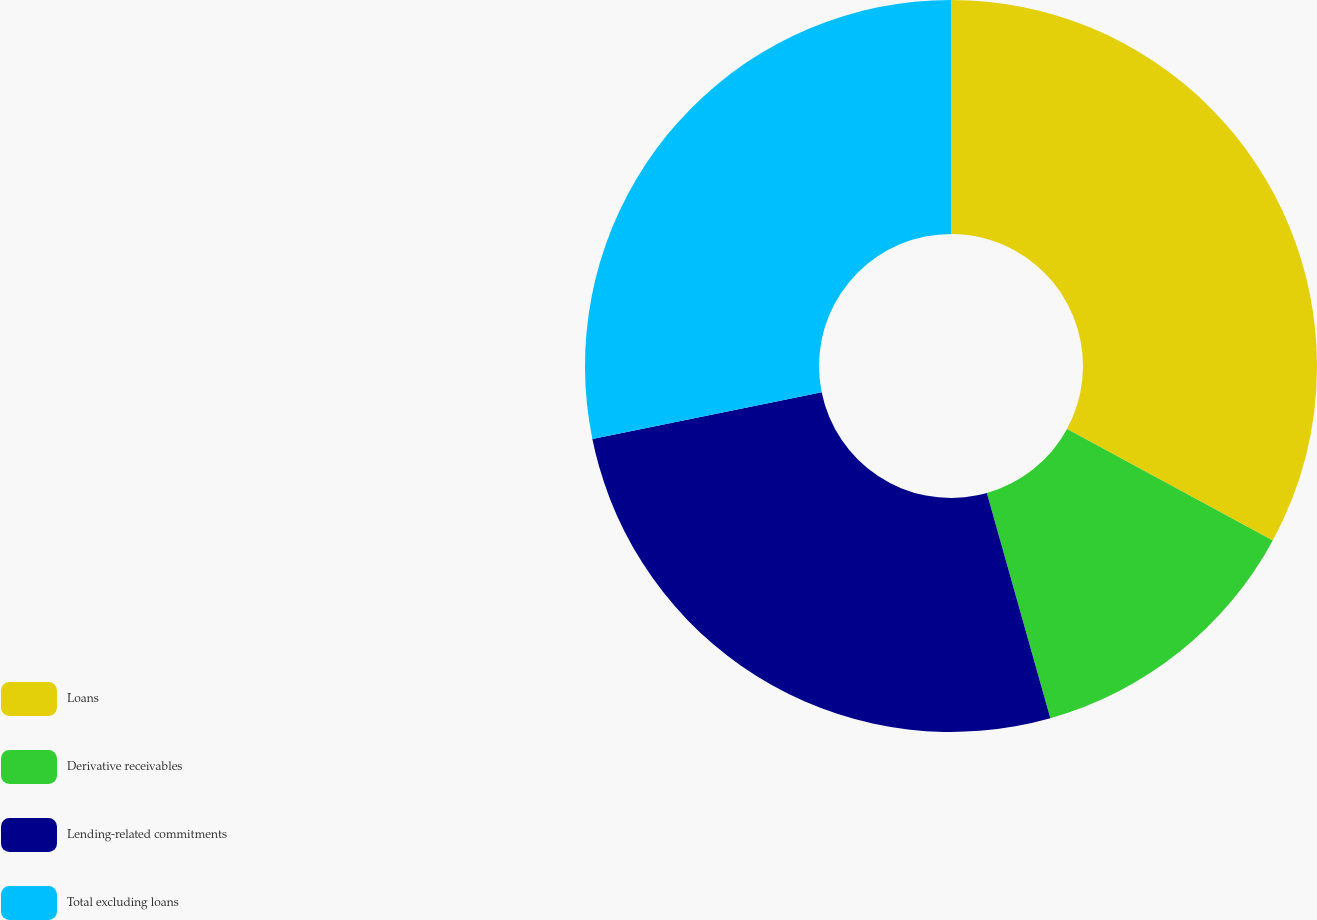Convert chart to OTSL. <chart><loc_0><loc_0><loc_500><loc_500><pie_chart><fcel>Loans<fcel>Derivative receivables<fcel>Lending-related commitments<fcel>Total excluding loans<nl><fcel>32.91%<fcel>12.72%<fcel>26.18%<fcel>28.2%<nl></chart> 